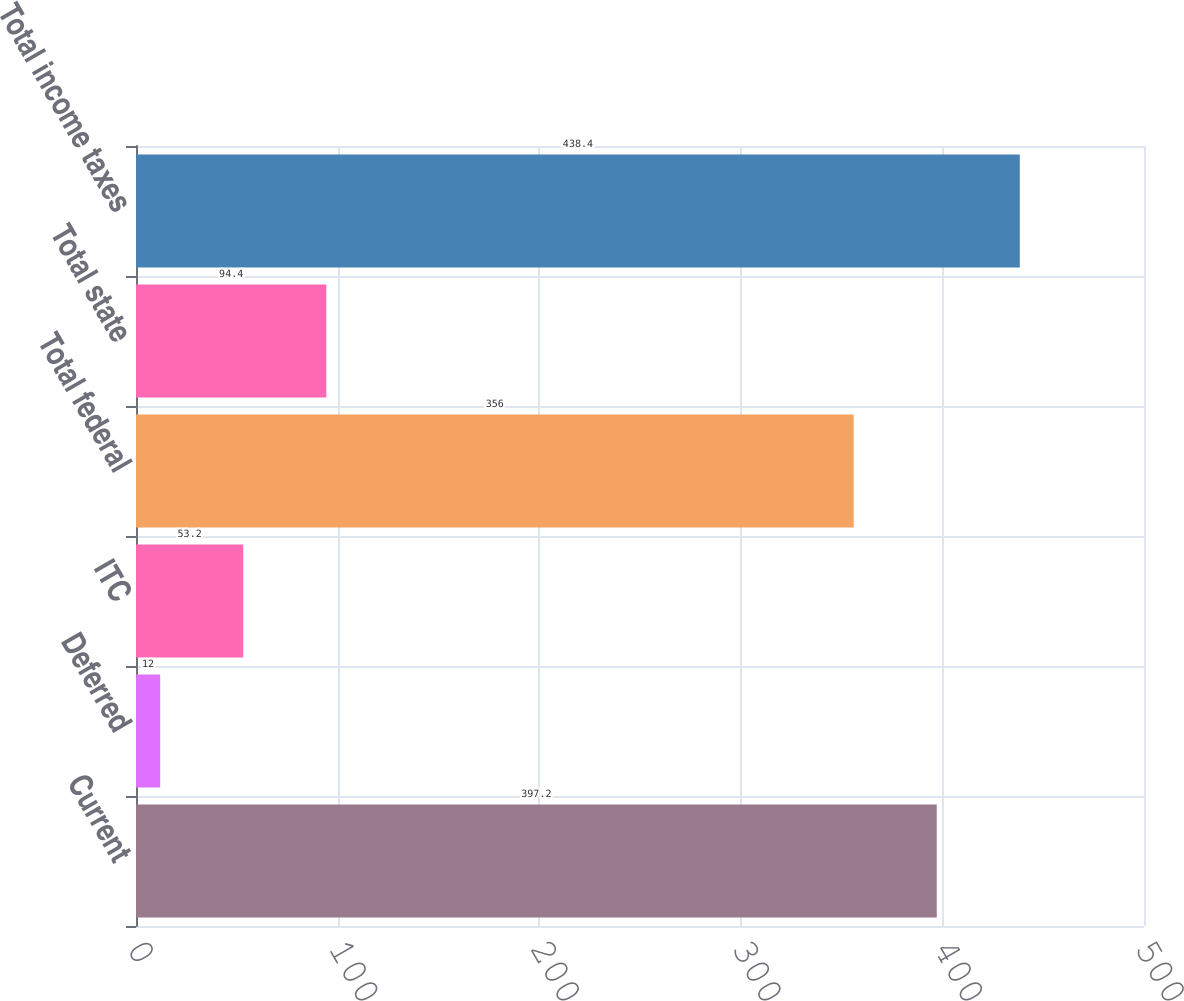Convert chart to OTSL. <chart><loc_0><loc_0><loc_500><loc_500><bar_chart><fcel>Current<fcel>Deferred<fcel>ITC<fcel>Total federal<fcel>Total state<fcel>Total income taxes<nl><fcel>397.2<fcel>12<fcel>53.2<fcel>356<fcel>94.4<fcel>438.4<nl></chart> 